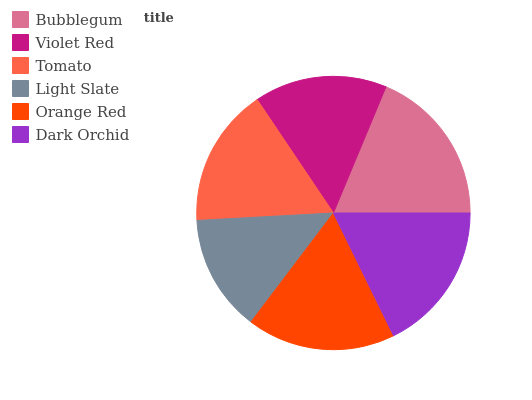Is Light Slate the minimum?
Answer yes or no. Yes. Is Bubblegum the maximum?
Answer yes or no. Yes. Is Violet Red the minimum?
Answer yes or no. No. Is Violet Red the maximum?
Answer yes or no. No. Is Bubblegum greater than Violet Red?
Answer yes or no. Yes. Is Violet Red less than Bubblegum?
Answer yes or no. Yes. Is Violet Red greater than Bubblegum?
Answer yes or no. No. Is Bubblegum less than Violet Red?
Answer yes or no. No. Is Orange Red the high median?
Answer yes or no. Yes. Is Tomato the low median?
Answer yes or no. Yes. Is Dark Orchid the high median?
Answer yes or no. No. Is Orange Red the low median?
Answer yes or no. No. 